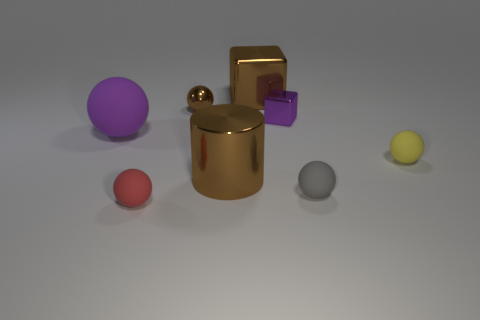What is the color of the rubber sphere that is both behind the small gray rubber ball and to the left of the small gray thing?
Provide a short and direct response. Purple. What is the shape of the small metal object to the left of the metal cube that is right of the block that is on the left side of the tiny purple cube?
Your answer should be very brief. Sphere. What color is the shiny object that is the same shape as the big purple rubber object?
Make the answer very short. Brown. There is a tiny rubber sphere that is left of the large brown block that is to the left of the purple shiny object; what is its color?
Keep it short and to the point. Red. What is the size of the brown shiny thing that is the same shape as the tiny purple thing?
Keep it short and to the point. Large. What number of large objects have the same material as the brown cylinder?
Your response must be concise. 1. There is a purple object that is on the left side of the large brown metallic cube; what number of gray rubber things are on the right side of it?
Give a very brief answer. 1. There is a small purple metal block; are there any tiny things behind it?
Your answer should be compact. Yes. There is a big shiny thing that is behind the yellow matte object; is it the same shape as the small purple metal thing?
Your answer should be compact. Yes. There is a thing that is the same color as the small metal block; what is its material?
Your answer should be compact. Rubber. 